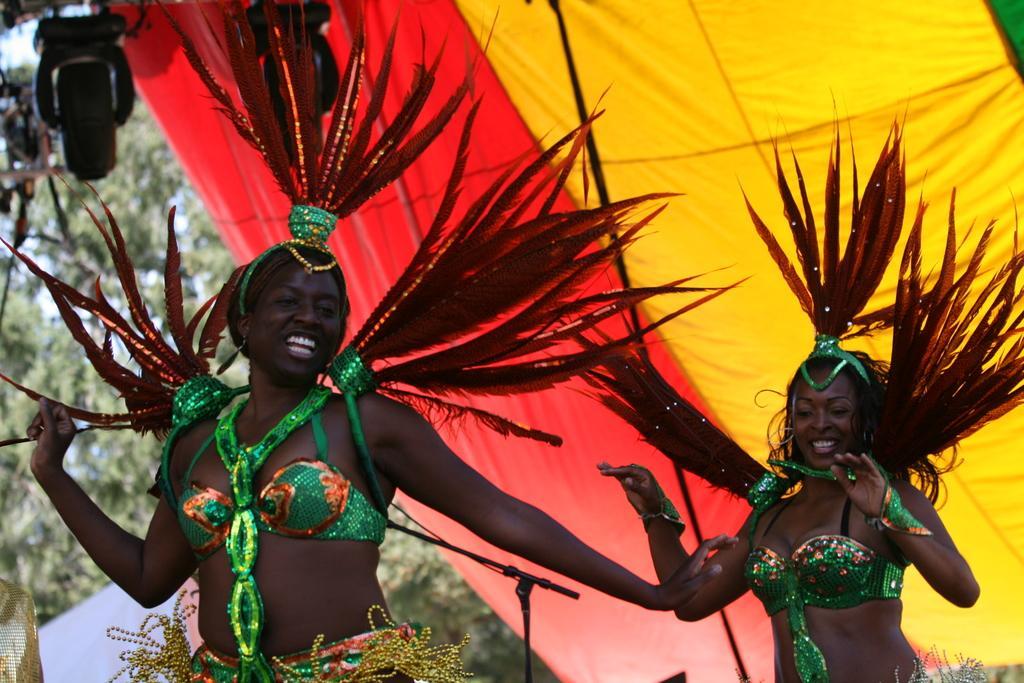How would you summarize this image in a sentence or two? In the foreground of this image, there are two women wearing carnival costume. Behind them, it seems like a tent and a light. In the background, there are trees and the sky. 